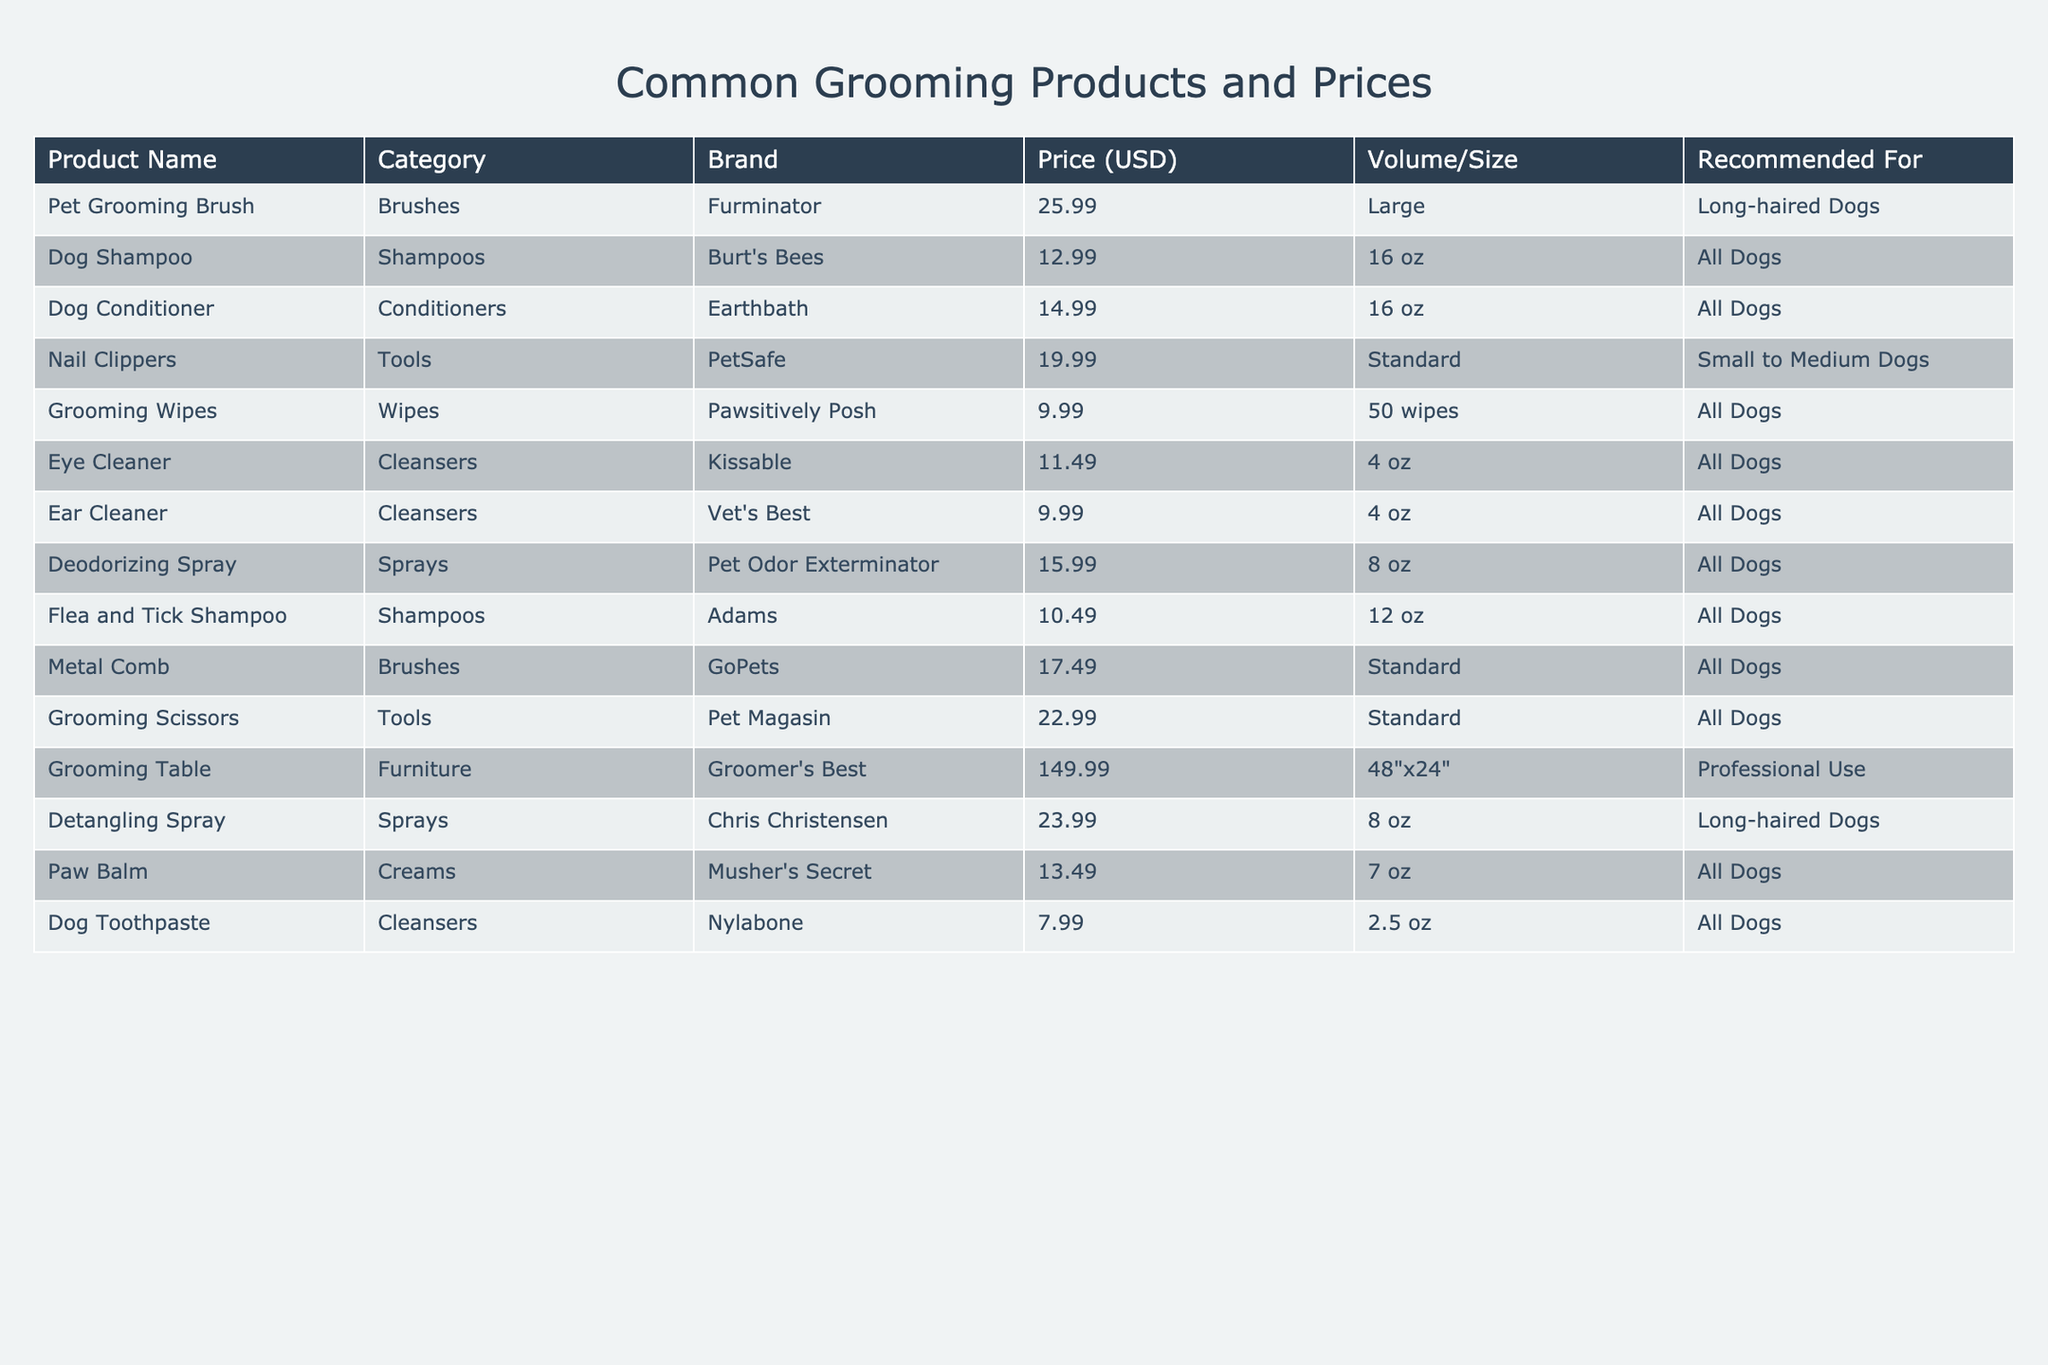What is the price of the Dog Shampoo? The price can be found in the table under the "Price (USD)" column next to the "Dog Shampoo" entry. It lists $12.99 as the price.
Answer: 12.99 Which product is recommended for long-haired dogs? In the table, the "Pet Grooming Brush" and "Detangling Spray" are both labeled as recommended for long-haired dogs, indicated in the "Recommended For" column.
Answer: Pet Grooming Brush, Detangling Spray What is the total cost of Nail Clippers and Dog Conditioner? To find the total cost, we add the prices of both items: Nail Clippers ($19.99) + Dog Conditioner ($14.99) = $34.98.
Answer: 34.98 Is there a product listed that is specifically for small to medium dogs? Yes, the "Nail Clippers" is specifically listed for small to medium dogs in the "Recommended For" column.
Answer: Yes Which product has the highest price? The table indicates that the "Grooming Table" has the highest price listed at $149.99 in the "Price (USD)" column.
Answer: Grooming Table What is the average price of all the grooming products? To find the average price, first sum all the prices: $25.99 + $12.99 + $14.99 + $19.99 + $9.99 + $11.49 + $9.99 + $15.99 + $10.49 + $17.49 + $22.99 + $149.99 + $23.99 + $13.49 + $7.99 = $433.84. There are 15 products, so the average is $433.84 / 15 = $28.92.
Answer: 28.92 Are there any products under $10? Yes, the "Grooming Wipes" and "Dog Toothpaste" are both under $10, indicated by their prices $9.99 and $7.99, respectively.
Answer: Yes If I buy all the items under the category "Cleansers," how much would it cost? The items under "Cleansers" are "Dog Toothpaste" ($7.99), "Eye Cleaner" ($11.49), and "Ear Cleaner" ($9.99). Adding them gives $7.99 + $11.49 + $9.99 = $29.47.
Answer: 29.47 Which brand offers a product containing flea and tick treatment? The "Flea and Tick Shampoo," listed under the "Shampoos" category, is the only product mentioned that provides flea and tick treatment. It is from the brand "Adams."
Answer: Adams What is the difference in price between the Dog Conditioner and the Dog Shampoo? The price of the Dog Conditioner is $14.99, and the Dog Shampoo is $12.99. The difference in price is $14.99 - $12.99 = $2.00.
Answer: 2.00 